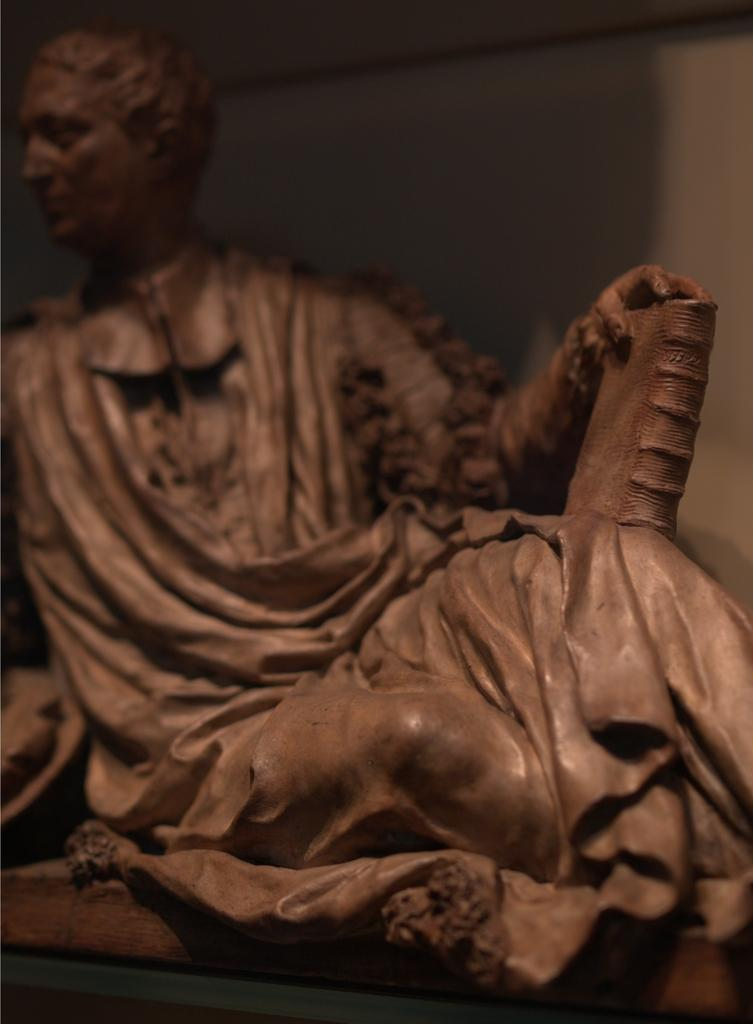What is the main subject of the image? There is a sculpture in the image. What color is the sculpture? The sculpture is brown in color. What can be seen in the background of the image? There is a wall in the background of the image. What type of pail is used to hold the sculpture in the image? There is no pail present in the image; the sculpture is not being held by any container. 